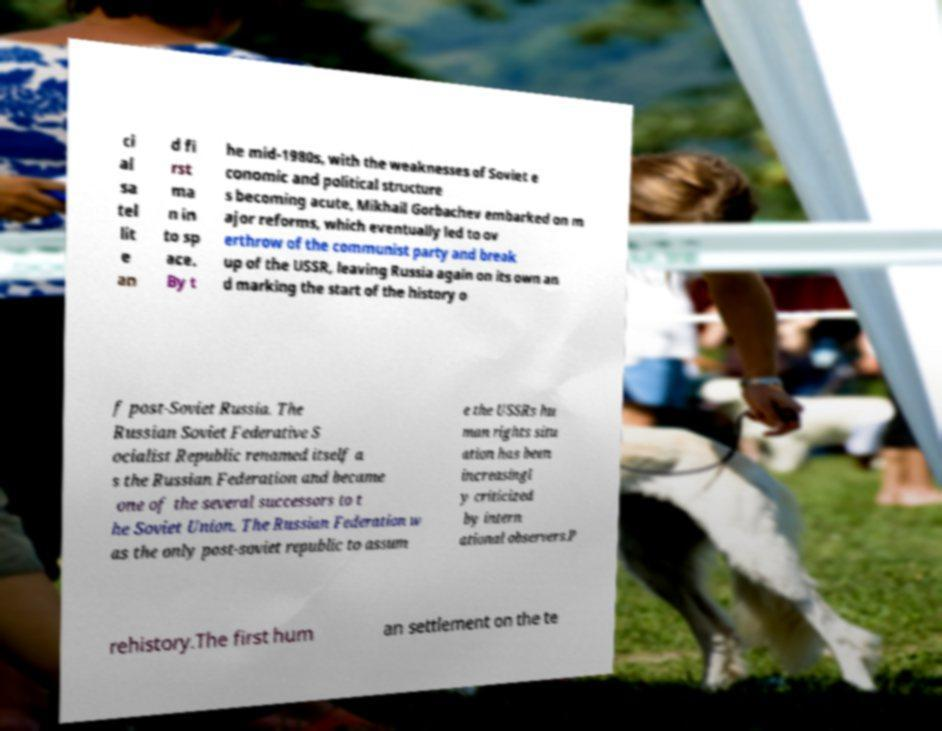Could you assist in decoding the text presented in this image and type it out clearly? ci al sa tel lit e an d fi rst ma n in to sp ace. By t he mid-1980s, with the weaknesses of Soviet e conomic and political structure s becoming acute, Mikhail Gorbachev embarked on m ajor reforms, which eventually led to ov erthrow of the communist party and break up of the USSR, leaving Russia again on its own an d marking the start of the history o f post-Soviet Russia. The Russian Soviet Federative S ocialist Republic renamed itself a s the Russian Federation and became one of the several successors to t he Soviet Union. The Russian Federation w as the only post-soviet republic to assum e the USSRs hu man rights situ ation has been increasingl y criticized by intern ational observers.P rehistory.The first hum an settlement on the te 